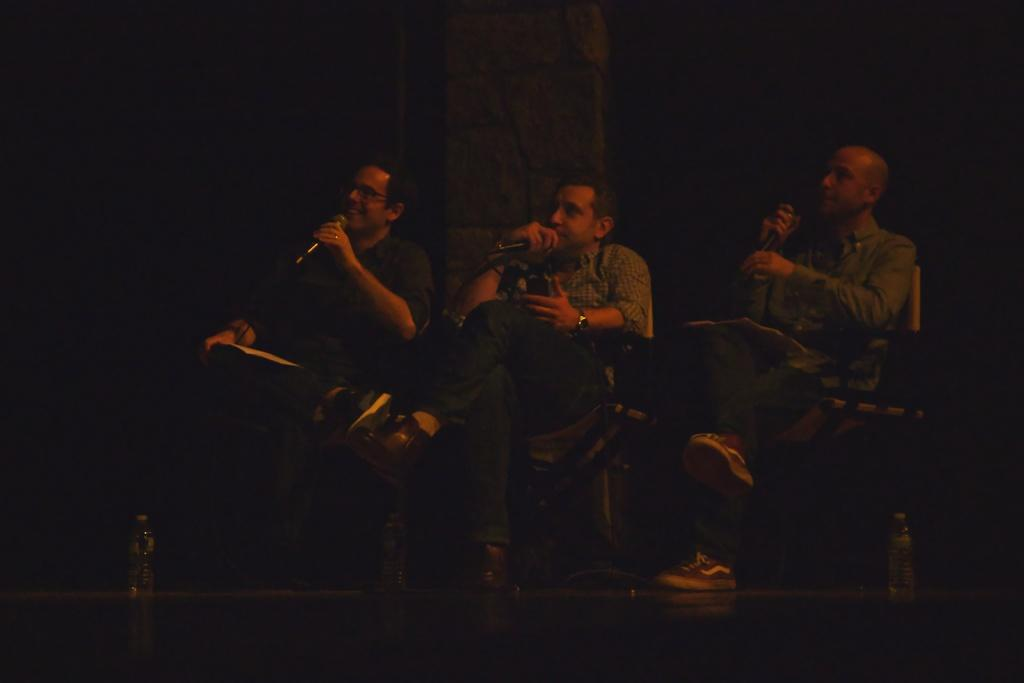How many people are in the image? There are three people in the image. What are the people doing in the image? The people are sitting on chairs and holding a mic. What can be seen in the background of the image? There is a pillar in the background of the image. What is visible at the bottom of the image? There is a floor visible at the bottom of the image. What type of notebook is lying on the street in the image? There is no notebook or street present in the image; it features three people sitting on chairs and holding a mic, with a pillar in the background and a floor visible at the bottom. 